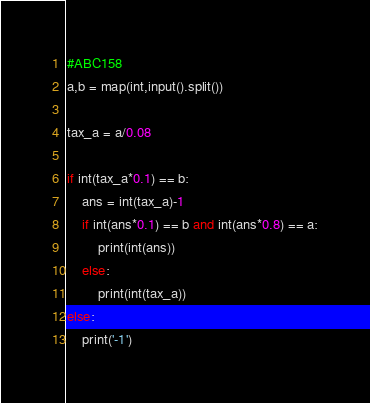<code> <loc_0><loc_0><loc_500><loc_500><_Python_>#ABC158
a,b = map(int,input().split())

tax_a = a/0.08

if int(tax_a*0.1) == b:
    ans = int(tax_a)-1
    if int(ans*0.1) == b and int(ans*0.8) == a:
        print(int(ans))
    else:
        print(int(tax_a))
else:
    print('-1')</code> 